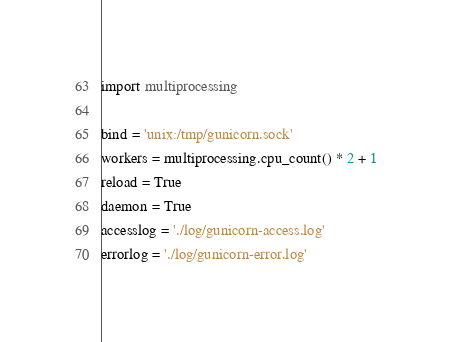<code> <loc_0><loc_0><loc_500><loc_500><_Python_>import multiprocessing

bind = 'unix:/tmp/gunicorn.sock'
workers = multiprocessing.cpu_count() * 2 + 1
reload = True
daemon = True
accesslog = './log/gunicorn-access.log'
errorlog = './log/gunicorn-error.log'

</code> 